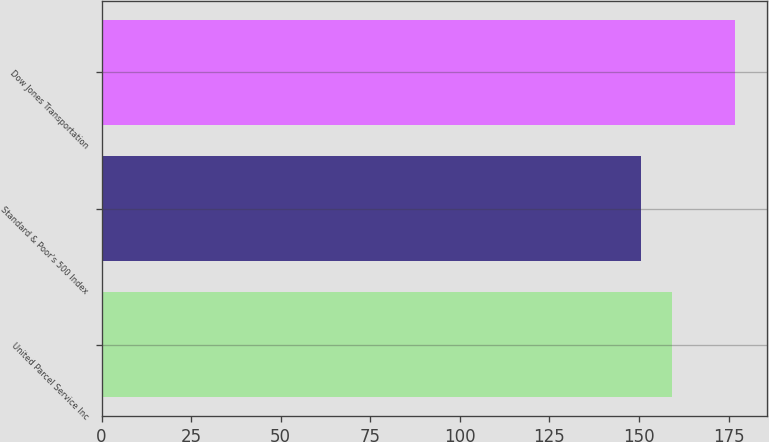Convert chart to OTSL. <chart><loc_0><loc_0><loc_500><loc_500><bar_chart><fcel>United Parcel Service Inc<fcel>Standard & Poor's 500 Index<fcel>Dow Jones Transportation<nl><fcel>159.23<fcel>150.49<fcel>176.83<nl></chart> 